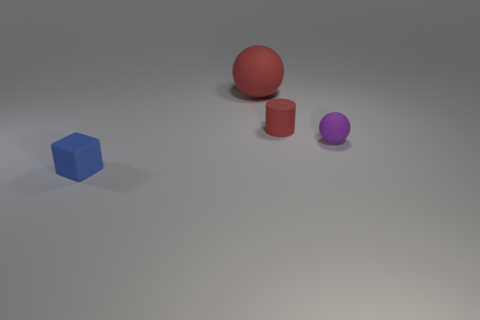How many objects are either tiny yellow spheres or matte objects that are to the right of the blue cube?
Offer a very short reply. 3. What is the color of the large rubber ball?
Ensure brevity in your answer.  Red. There is a sphere right of the big red thing that is behind the rubber ball in front of the cylinder; what is its material?
Offer a very short reply. Rubber. There is another sphere that is made of the same material as the small sphere; what is its size?
Offer a terse response. Large. Are there any big objects that have the same color as the matte cylinder?
Keep it short and to the point. Yes. Do the rubber cylinder and the rubber sphere left of the tiny matte ball have the same size?
Your answer should be compact. No. How many red matte things are on the left side of the small thing to the left of the ball behind the tiny purple matte thing?
Ensure brevity in your answer.  0. The matte sphere that is the same color as the tiny cylinder is what size?
Keep it short and to the point. Large. Are there any big red things behind the big matte ball?
Ensure brevity in your answer.  No. What shape is the purple thing?
Offer a terse response. Sphere. 